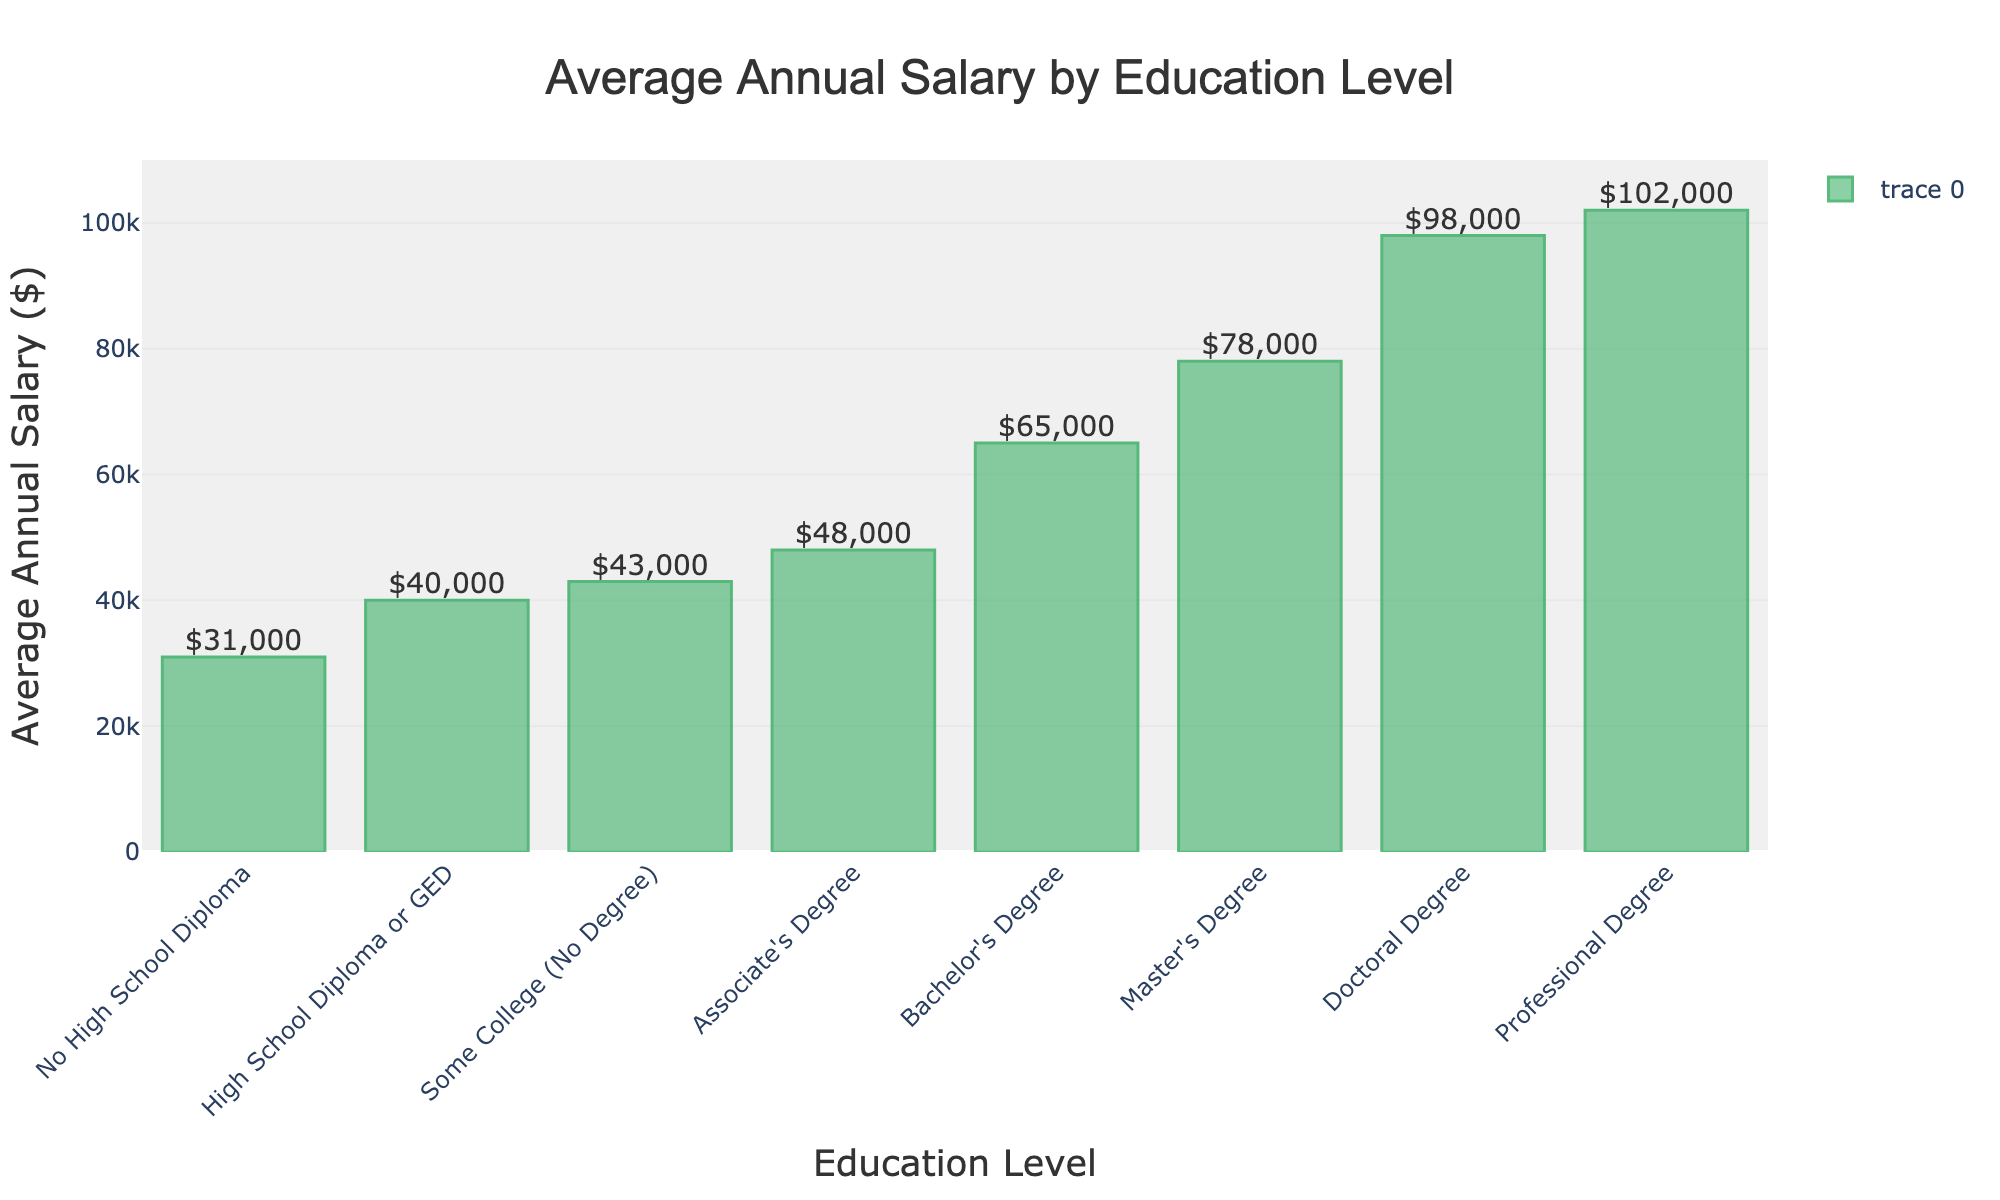what is the highest average annual salary by education level? The highest average annual salary is indicated by the tallest bar in the chart. The tallest bar corresponds to "Professional Degree" with an average annual salary of $102,000.
Answer: $102,000 How much more does a bachelor's degree holder earn on average compared to a high school diploma or GED holder? The average salary for a bachelor's degree is $65,000 and for a high school diploma or GED is $40,000. The difference is calculated as $65,000 - $40,000 = $25,000.
Answer: $25,000 Compare the average annual salaries between someone with a master's degree and someone with an associate's degree. The average annual salary for a master's degree is $78,000 and for an associate's degree is $48,000. Comparing these values, $78,000 is greater than $48,000.
Answer: master's degree > associate's degree How does the average salary change from having some college (no degree) to having an associate's degree? The average salary with some college (no degree) is $43,000, and with an associate's degree, it is $48,000. The increase is $48,000 - $43,000 = $5,000.
Answer: $5,000 increase What's the difference in average annual salary between someone with a doctoral degree and someone with a master's degree? The average annual salary for a doctoral degree is $98,000 and for a master's degree is $78,000. The difference is $98,000 - $78,000 = $20,000.
Answer: $20,000 Which education level has a lower average annual salary, some college (no degree) or an associate's degree, and by how much? The average annual salary for some college (no degree) is $43,000 and for an associate's degree is $48,000. The difference is $48,000 - $43,000 = $5,000, where some college (no degree) is lower.
Answer: some college (no degree) by $5,000 What is the total sum of the average annual salaries for all education levels? Adding up the average annual salaries: $31,000 + $40,000 + $43,000 + $48,000 + $65,000 + $78,000 + $98,000 + $102,000 = $505,000.
Answer: $505,000 What is the average annual salary of a professional degree in comparison to a doctoral degree? The average annual salary for a professional degree is $102,000 and for a doctoral degree is $98,000. Comparing these values, $102,000 is greater than $98,000.
Answer: professional degree > doctoral degree Between which two consecutive education levels is there the largest increase in average annual salary? Reviewing the differences: ($40,000 - $31,000 = $9,000), ($43,000 - $40,000 = $3,000), ($48,000 - $43,000 = $5,000), ($65,000 - $48,000 = $17,000), ($78,000 - $65,000 = $13,000), ($98,000 - $78,000 = $20,000), ($102,000 - $98,000 = $4,000). The largest increase is $20,000 between master's and doctoral degrees.
Answer: master's to doctoral What is the percentage increase in average annual salary from a bachelor's degree to a master's degree? The average annual salary for a bachelor's degree is $65,000 and for a master's degree is $78,000. The percentage increase is calculated as (($78,000 - $65,000) / $65,000) * 100 = 20%.
Answer: 20% 